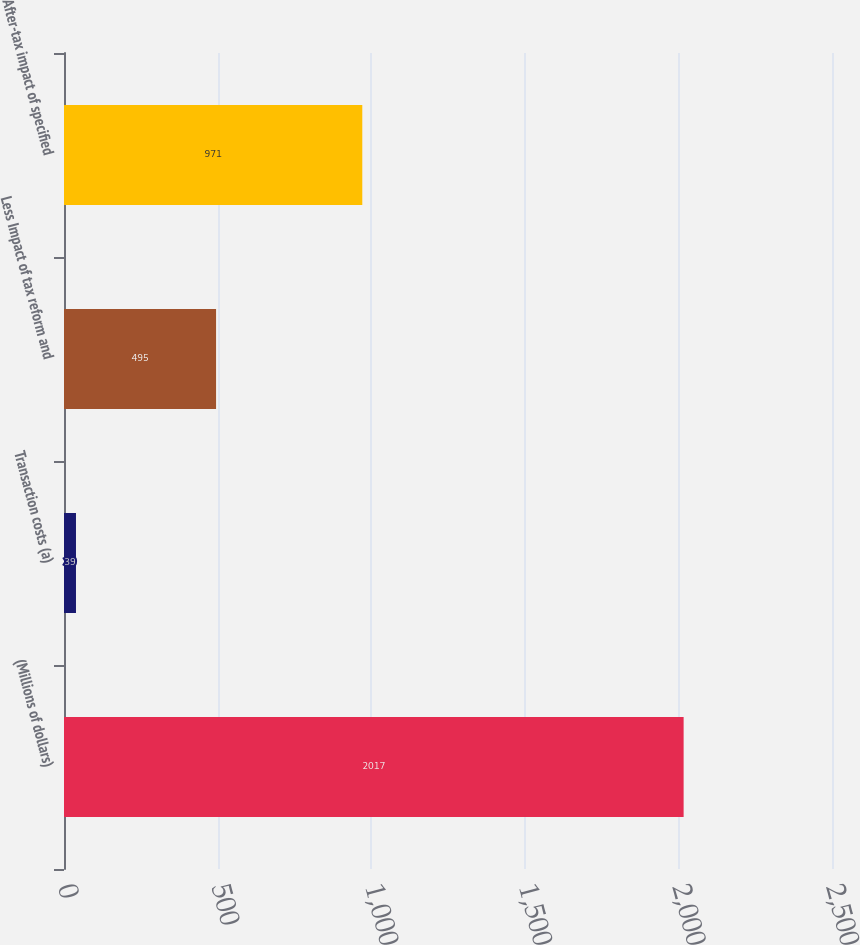Convert chart to OTSL. <chart><loc_0><loc_0><loc_500><loc_500><bar_chart><fcel>(Millions of dollars)<fcel>Transaction costs (a)<fcel>Less Impact of tax reform and<fcel>After-tax impact of specified<nl><fcel>2017<fcel>39<fcel>495<fcel>971<nl></chart> 